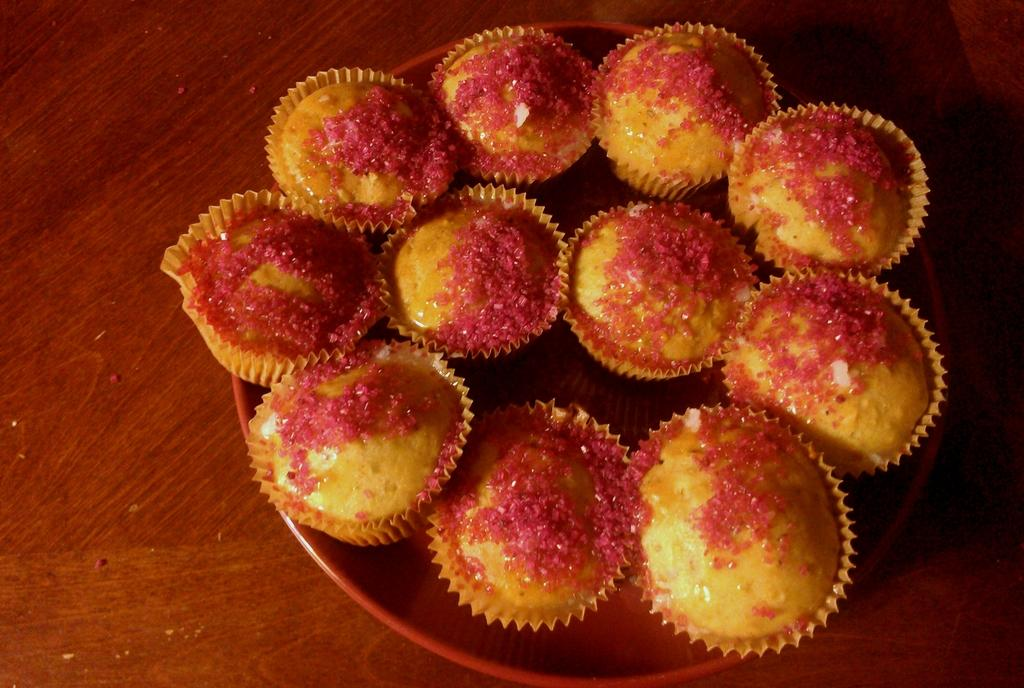What type of dessert can be seen in the image? There are cupcakes in the image. How are the cupcakes arranged in the image? The cupcakes are on a plate. What is the surface beneath the plate in the image? The plate is on a wooden surface. What type of experience can be gained from the harmony of the cupcakes in the image? There is no mention of harmony or an experience in the image; it simply shows cupcakes on a plate. 